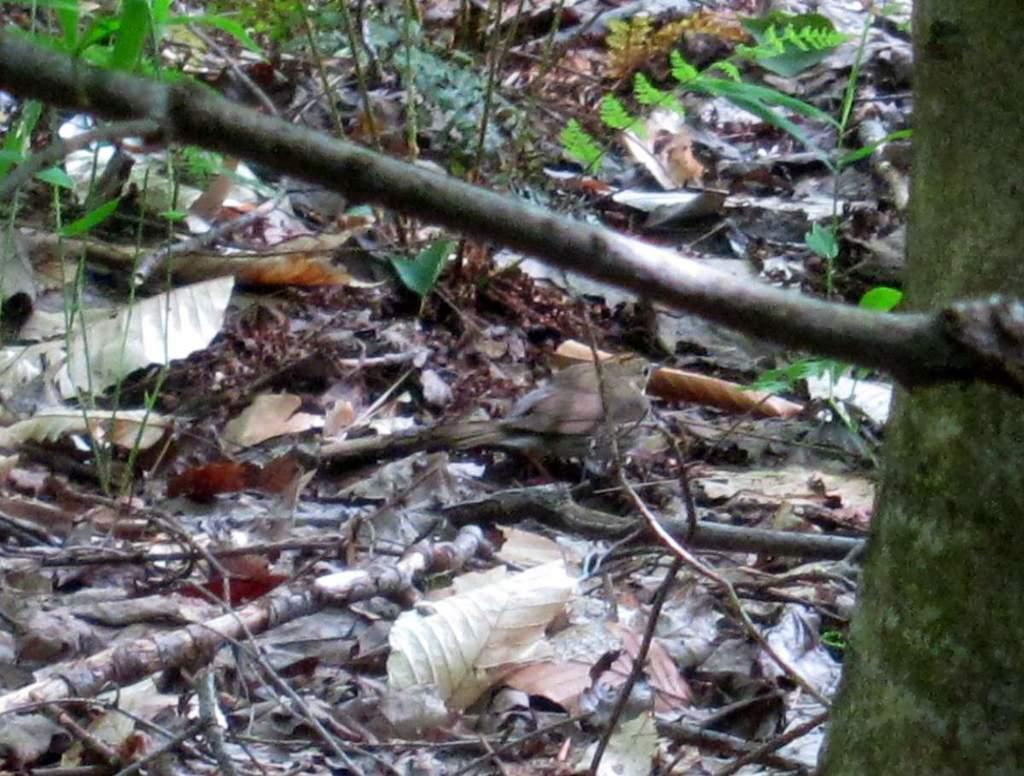What type of vegetation can be seen in the image? There are leaves in the image. What else is present in the image besides leaves? There are sticks in the image. Can you describe the stem visible in the image? There is a stem on the right side of the image. What type of hat is being worn by the nation in the image? There is no nation or hat present in the image; it features leaves, sticks, and a stem. 